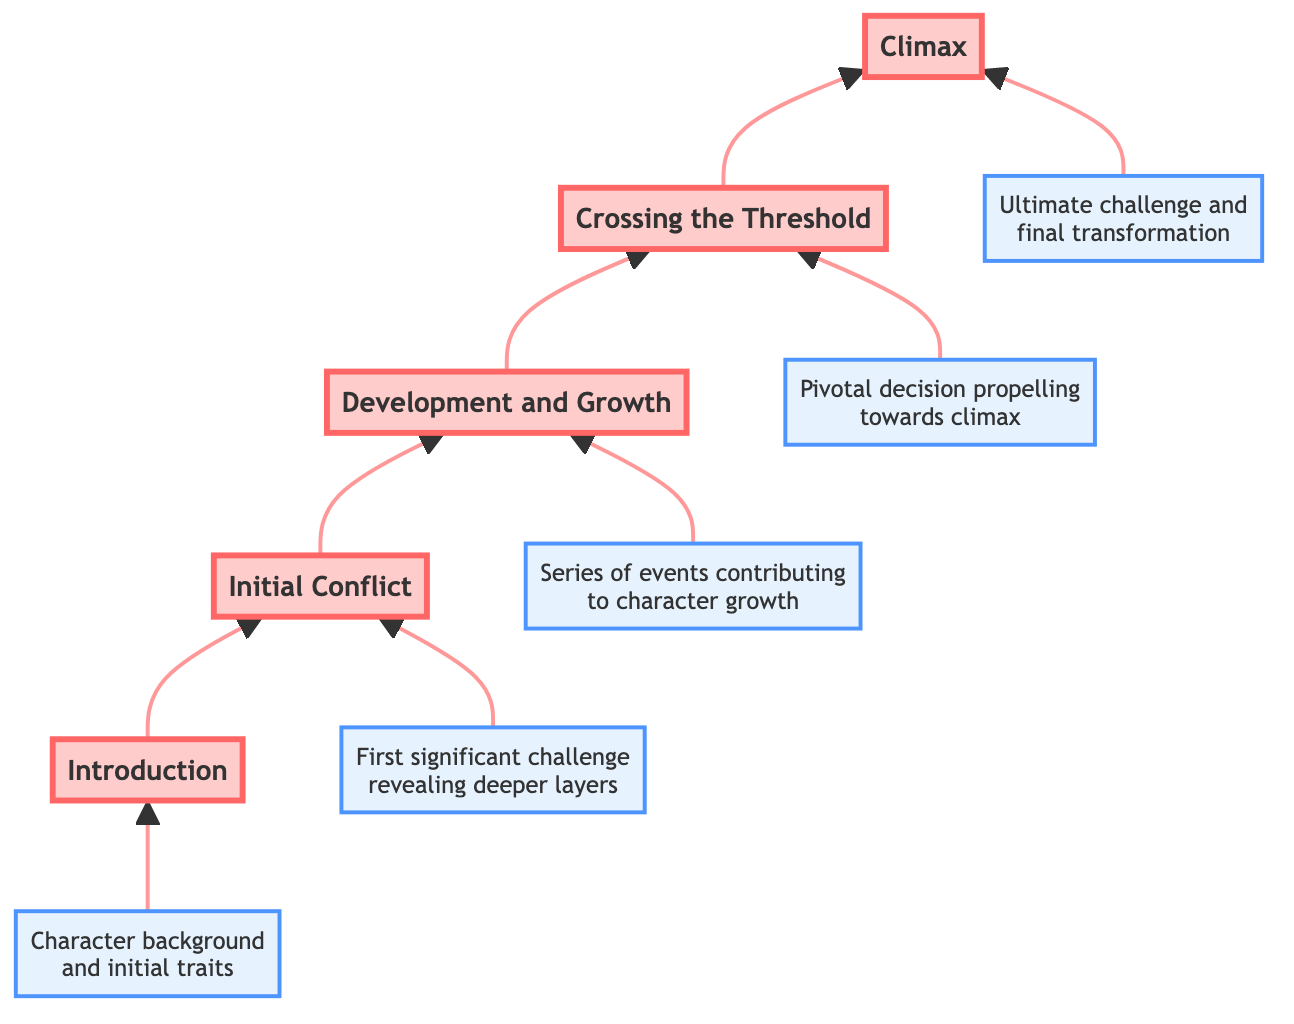What is the top stage in the flow chart? The flow chart progresses upwards from the introduction stage. The stage at the top of the chart, which is the final step in the character's evolution, is the Climax.
Answer: Climax How many stages are there in total? The diagram shows a sequence of five distinct stages from Introduction to Climax, making the total count of stages five.
Answer: 5 What leads into the Development and Growth stage? The Development and Growth stage follows the Initial Conflict stage, depicting a progression where character growth is influenced by the initial obstacles presented.
Answer: Initial Conflict Which stage involves a pivotal decision? The stage that focuses on a critical turning point in the character's journey, where a significant choice is made, is clearly labeled as the Crossing the Threshold stage.
Answer: Crossing the Threshold What is the description of the Introduction stage? The Introduction stage lays the foundation for the character by providing basic background and initial traits, as well as their context within the story.
Answer: Introduction of the character, including basic background, initial traits, and setting within the story Which two stages come after Initial Conflict? Following the Initial Conflict, the chart shows a clear flow into two subsequent stages: Development and Growth, followed by Crossing the Threshold.
Answer: Development and Growth, Crossing the Threshold What is the relationship between Climax and Development and Growth? In the flow of the diagram, the relationship indicates that the Climax stage comes after Development and Growth, which suggests that the character's growth contributes directly to their ultimate challenge.
Answer: Climax comes after Development and Growth Which author's character is featured in the Climax? The Climax references characters from different works, with one mention being Frodo Baggins from 'The Lord of the Rings' by J.R.R. Tolkien.
Answer: Frodo Baggins What are the initial traits mentioned in the Introduction stage? The Introduction stage points to the character's background and traits, emphasizing aspects like Jay Gatsby's mysterious persona and Elizabeth Bennet's intelligence.
Answer: Jay Gatsby's mysterious persona, Elizabeth Bennet's wit and intelligence 